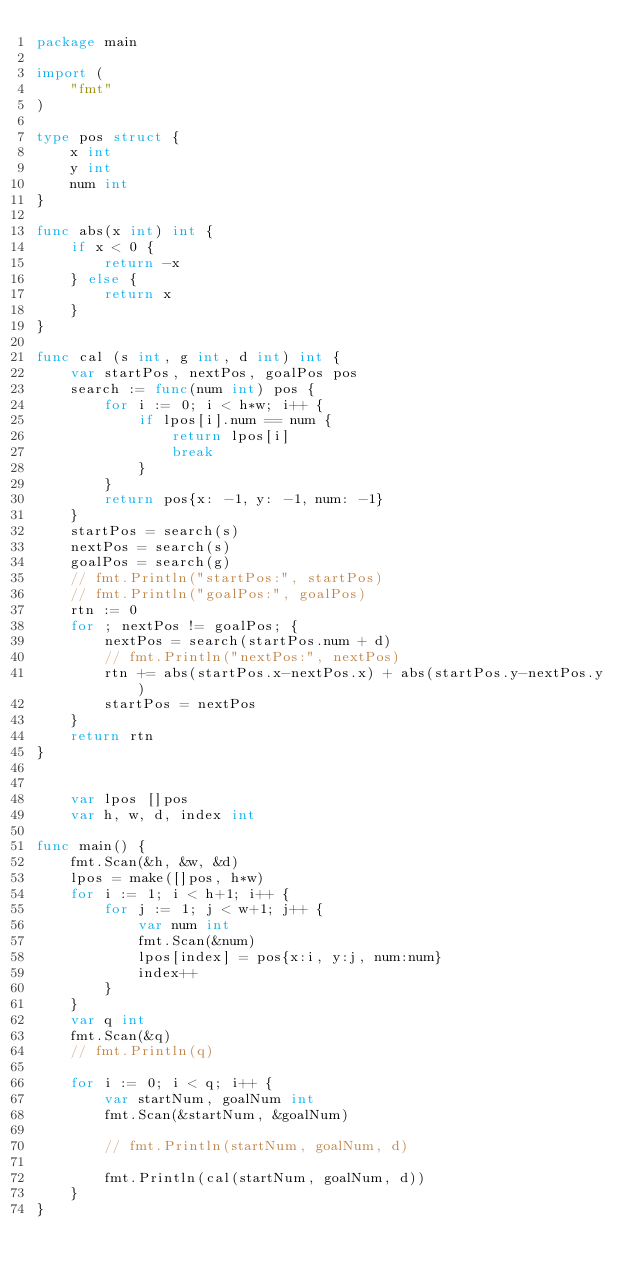<code> <loc_0><loc_0><loc_500><loc_500><_Go_>package main

import (
	"fmt"
)

type pos struct {
	x int
	y int
	num int
}

func abs(x int) int {
	if x < 0 {
		return -x
	} else {
		return x
	}
}

func cal (s int, g int, d int) int {
	var startPos, nextPos, goalPos pos
	search := func(num int) pos {
		for i := 0; i < h*w; i++ {
			if lpos[i].num == num {
				return lpos[i]
				break
			}
		}
		return pos{x: -1, y: -1, num: -1}
	}
	startPos = search(s)
	nextPos = search(s)
	goalPos = search(g)
	// fmt.Println("startPos:", startPos)
	// fmt.Println("goalPos:", goalPos)
	rtn := 0
	for ; nextPos != goalPos; {
		nextPos = search(startPos.num + d)
		// fmt.Println("nextPos:", nextPos)
		rtn += abs(startPos.x-nextPos.x) + abs(startPos.y-nextPos.y)
		startPos = nextPos
	}
	return rtn
}


	var lpos []pos
	var h, w, d, index int

func main() {
	fmt.Scan(&h, &w, &d)
	lpos = make([]pos, h*w)
	for i := 1; i < h+1; i++ {
		for j := 1; j < w+1; j++ {
			var num int
			fmt.Scan(&num)
			lpos[index] = pos{x:i, y:j, num:num}
			index++
		}
	}
	var q int
	fmt.Scan(&q)
	// fmt.Println(q)

	for i := 0; i < q; i++ {
		var startNum, goalNum int
		fmt.Scan(&startNum, &goalNum)

		// fmt.Println(startNum, goalNum, d)

		fmt.Println(cal(startNum, goalNum, d))
	}
}
</code> 